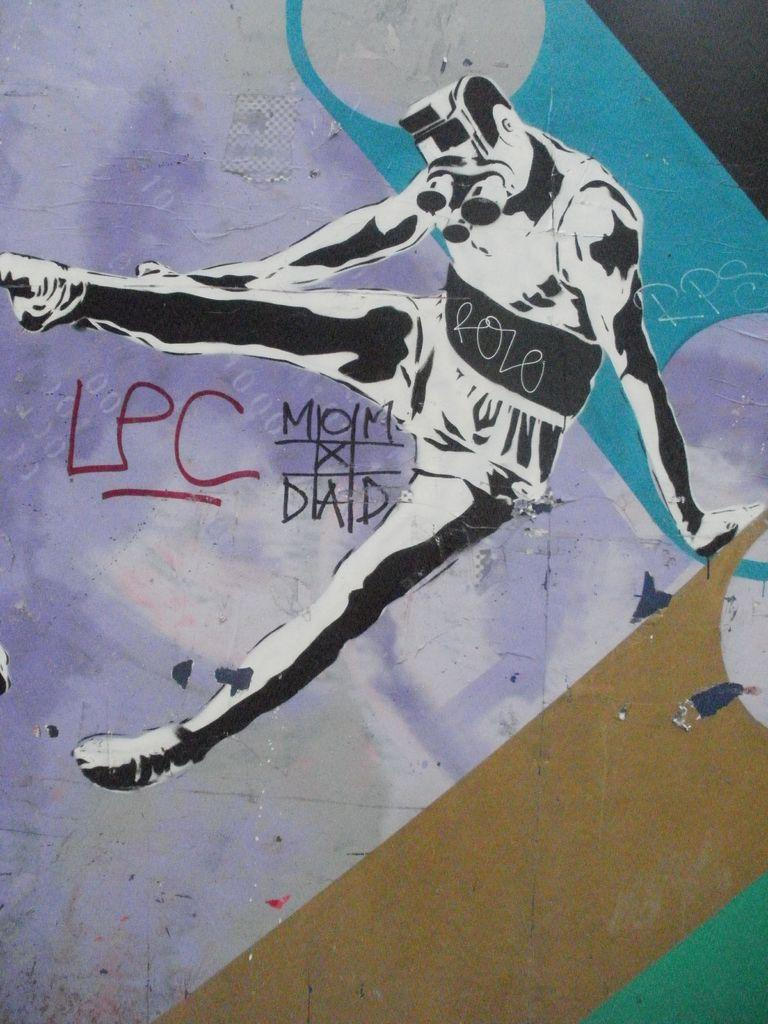What is depicted on the poster in the image? The poster is a painting of a person. What else can be seen on the poster besides the person? There is writing on the poster. What day of the week is depicted in the painting on the poster? The image does not depict a day of the week; it is a painting of a person. What type of tray is used to hold the painting on the poster? There is no tray present in the image; it is a poster with writing and a painting of a person. 